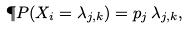<formula> <loc_0><loc_0><loc_500><loc_500>\P P ( X _ { i } = \lambda _ { j , k } ) = p _ { j } \, \lambda _ { j , k } ,</formula> 